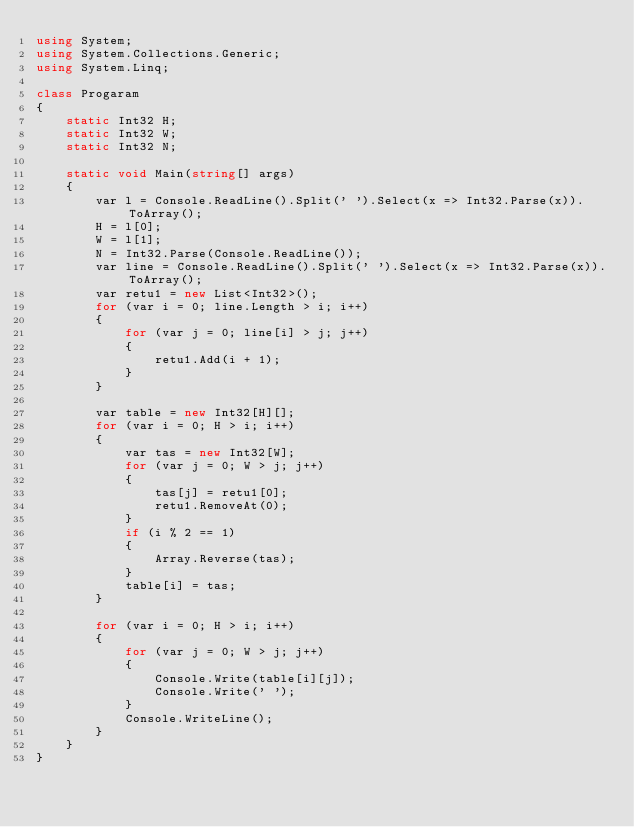<code> <loc_0><loc_0><loc_500><loc_500><_C#_>using System;
using System.Collections.Generic;
using System.Linq;

class Progaram
{
    static Int32 H;
    static Int32 W;
    static Int32 N;

    static void Main(string[] args)
    {
        var l = Console.ReadLine().Split(' ').Select(x => Int32.Parse(x)).ToArray();
        H = l[0];
        W = l[1];
        N = Int32.Parse(Console.ReadLine());
        var line = Console.ReadLine().Split(' ').Select(x => Int32.Parse(x)).ToArray();
        var retu1 = new List<Int32>();
        for (var i = 0; line.Length > i; i++)
        {
            for (var j = 0; line[i] > j; j++)
            {
                retu1.Add(i + 1);
            }
        }

        var table = new Int32[H][];
        for (var i = 0; H > i; i++)
        {
            var tas = new Int32[W];
            for (var j = 0; W > j; j++)
            {
                tas[j] = retu1[0];
                retu1.RemoveAt(0);
            }
            if (i % 2 == 1)
            {
                Array.Reverse(tas);
            }
            table[i] = tas;
        }
     
        for (var i = 0; H > i; i++)
        {
            for (var j = 0; W > j; j++)
            {
                Console.Write(table[i][j]);
                Console.Write(' ');
            }
            Console.WriteLine();
        }
    }
}
</code> 